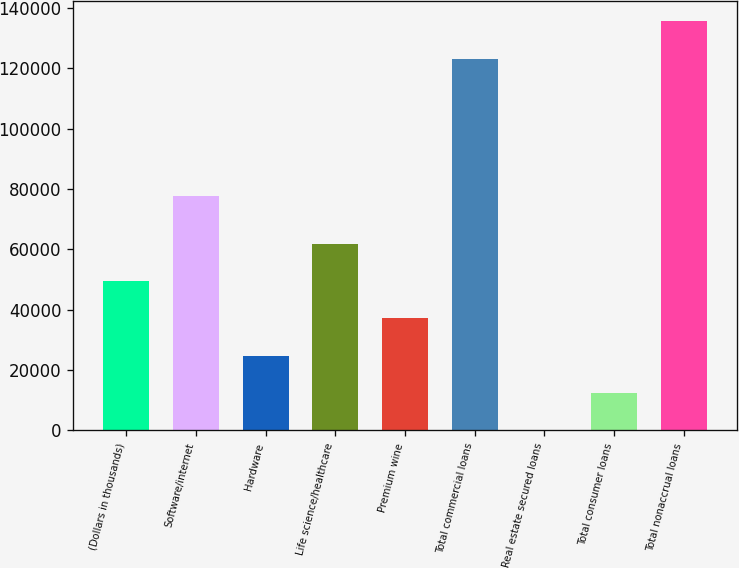Convert chart to OTSL. <chart><loc_0><loc_0><loc_500><loc_500><bar_chart><fcel>(Dollars in thousands)<fcel>Software/internet<fcel>Hardware<fcel>Life science/healthcare<fcel>Premium wine<fcel>Total commercial loans<fcel>Real estate secured loans<fcel>Total consumer loans<fcel>Total nonaccrual loans<nl><fcel>49442.6<fcel>77545<fcel>24792.8<fcel>61767.5<fcel>37117.7<fcel>123249<fcel>143<fcel>12467.9<fcel>135574<nl></chart> 